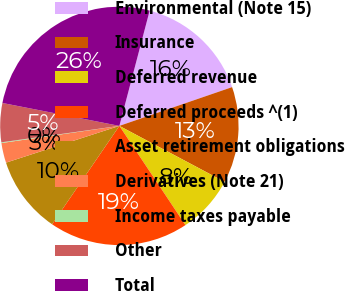Convert chart to OTSL. <chart><loc_0><loc_0><loc_500><loc_500><pie_chart><fcel>Environmental (Note 15)<fcel>Insurance<fcel>Deferred revenue<fcel>Deferred proceeds ^(1)<fcel>Asset retirement obligations<fcel>Derivatives (Note 21)<fcel>Income taxes payable<fcel>Other<fcel>Total<nl><fcel>15.64%<fcel>13.05%<fcel>7.87%<fcel>18.9%<fcel>10.46%<fcel>2.69%<fcel>0.1%<fcel>5.28%<fcel>26.01%<nl></chart> 